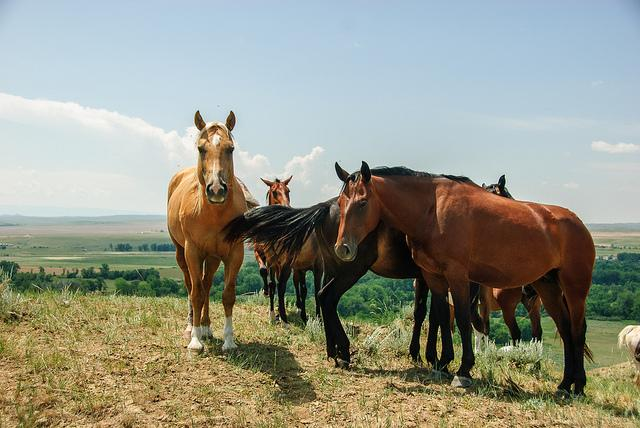What is above the horses?

Choices:
A) fly
B) kite
C) sky
D) dragon sky 